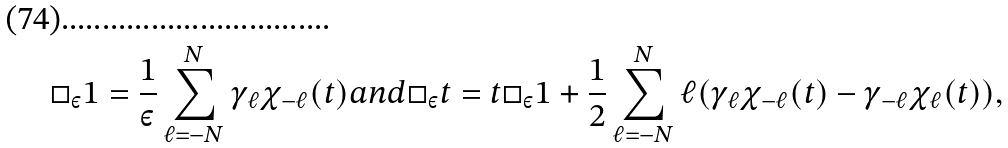Convert formula to latex. <formula><loc_0><loc_0><loc_500><loc_500>\Box _ { \varepsilon } 1 = \frac { 1 } { \varepsilon } \sum _ { \ell = - N } ^ { N } \gamma _ { \ell } \chi _ { - \ell } ( t ) a n d \Box _ { \varepsilon } t = t \Box _ { \varepsilon } 1 + \frac { 1 } { 2 } \sum _ { \ell = - N } ^ { N } \ell ( \gamma _ { \ell } \chi _ { - \ell } ( t ) - \gamma _ { - \ell } \chi _ { \ell } ( t ) ) ,</formula> 